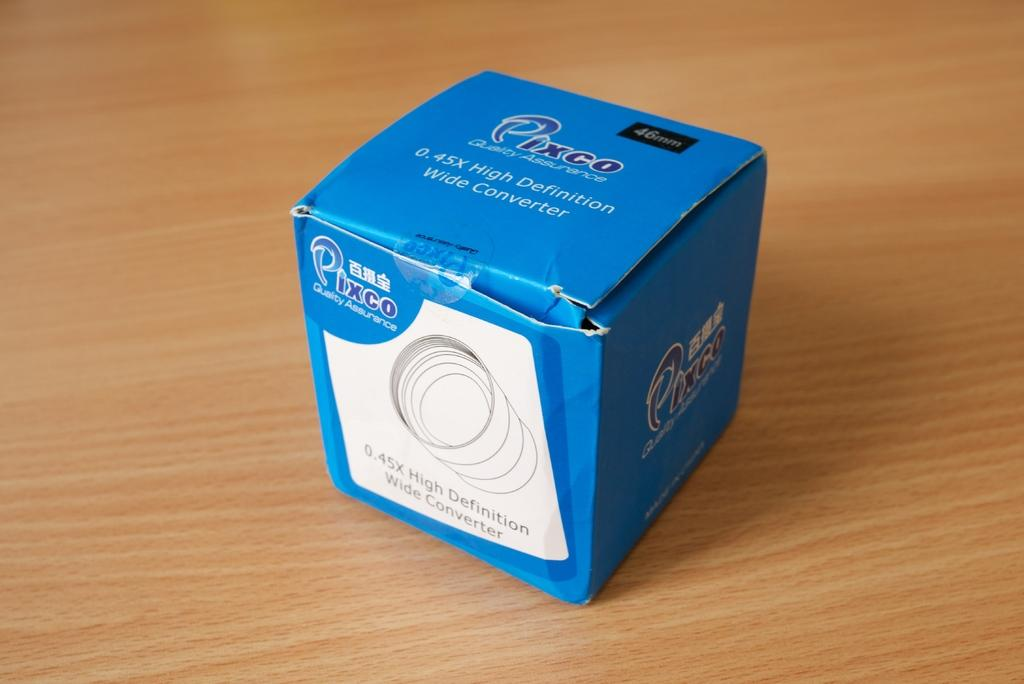<image>
Render a clear and concise summary of the photo. A blue cardboard square is labeled as being from Pixco. 